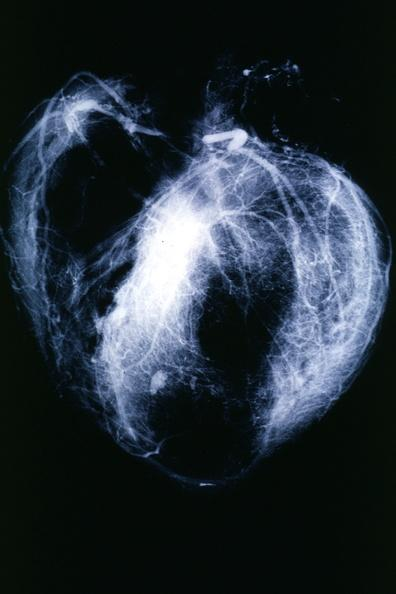does this image show postmortangiogram with apparent lesions in proximal right coronary?
Answer the question using a single word or phrase. Yes 